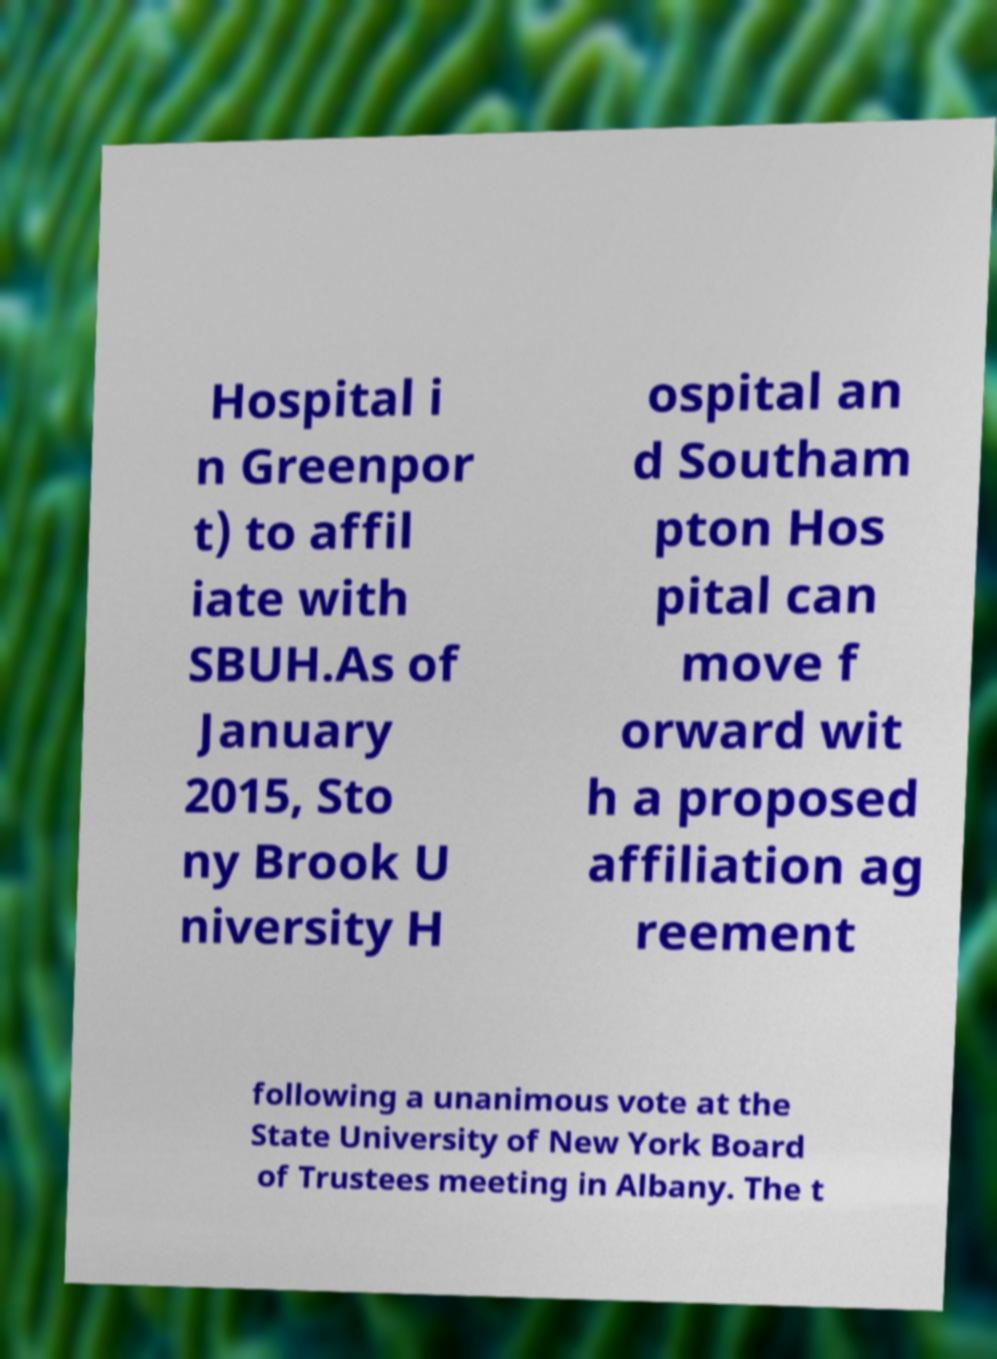I need the written content from this picture converted into text. Can you do that? Hospital i n Greenpor t) to affil iate with SBUH.As of January 2015, Sto ny Brook U niversity H ospital an d Southam pton Hos pital can move f orward wit h a proposed affiliation ag reement following a unanimous vote at the State University of New York Board of Trustees meeting in Albany. The t 